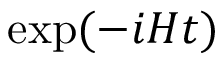<formula> <loc_0><loc_0><loc_500><loc_500>\exp ( - i H t )</formula> 